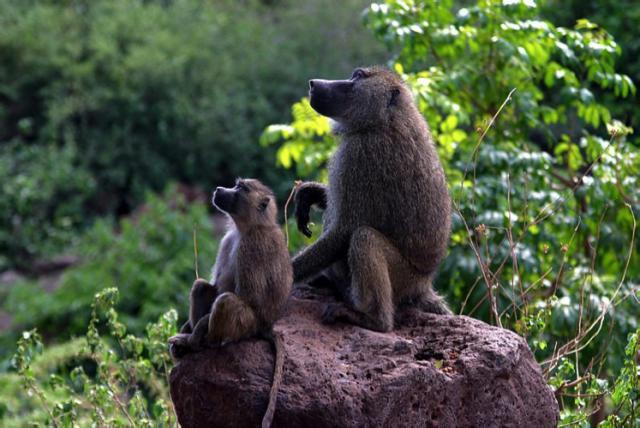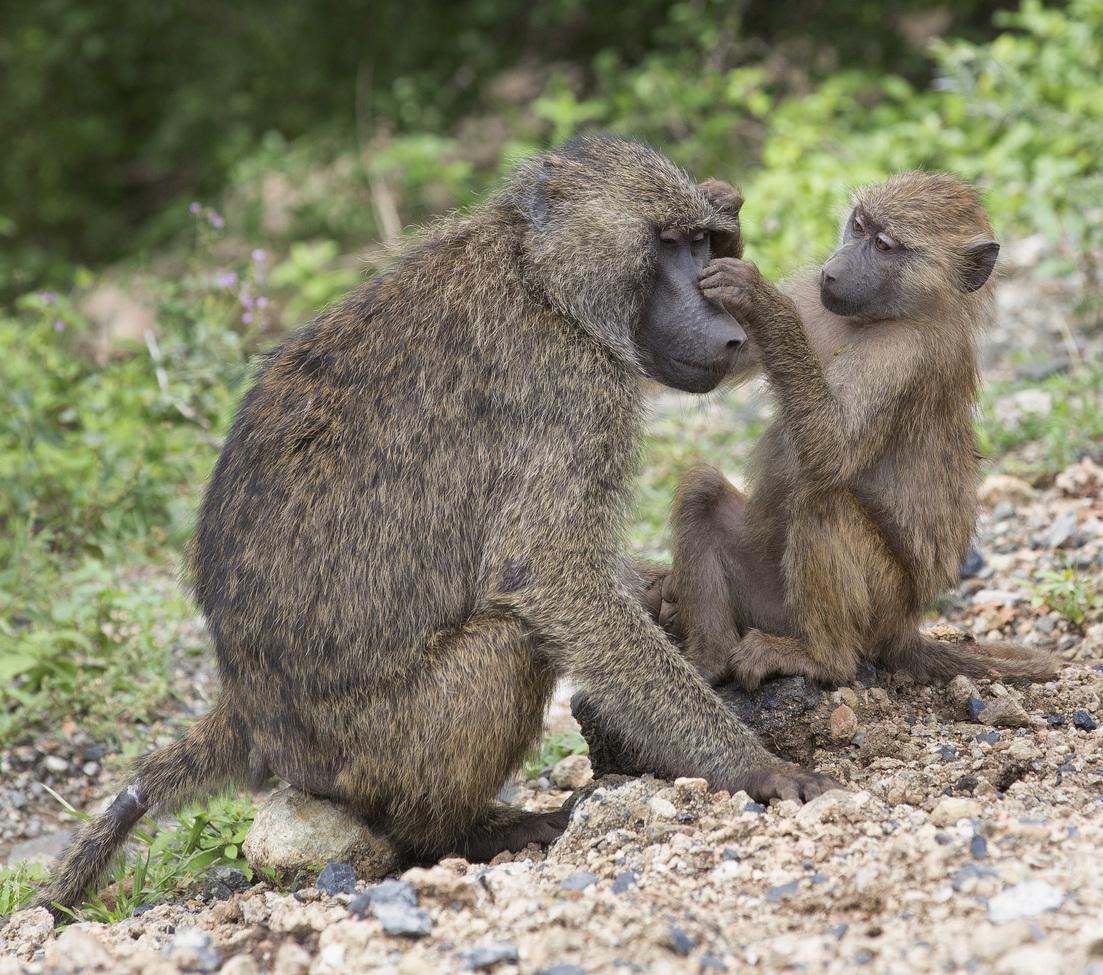The first image is the image on the left, the second image is the image on the right. Given the left and right images, does the statement "No more than 2 baboons in either picture." hold true? Answer yes or no. Yes. 